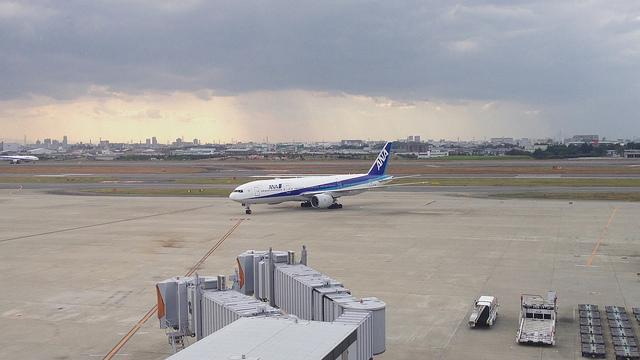Is this an airport?
Short answer required. Yes. Are there people by the plane?
Quick response, please. No. Is the sun shining?
Be succinct. No. How many planes on the runway?
Keep it brief. 1. 